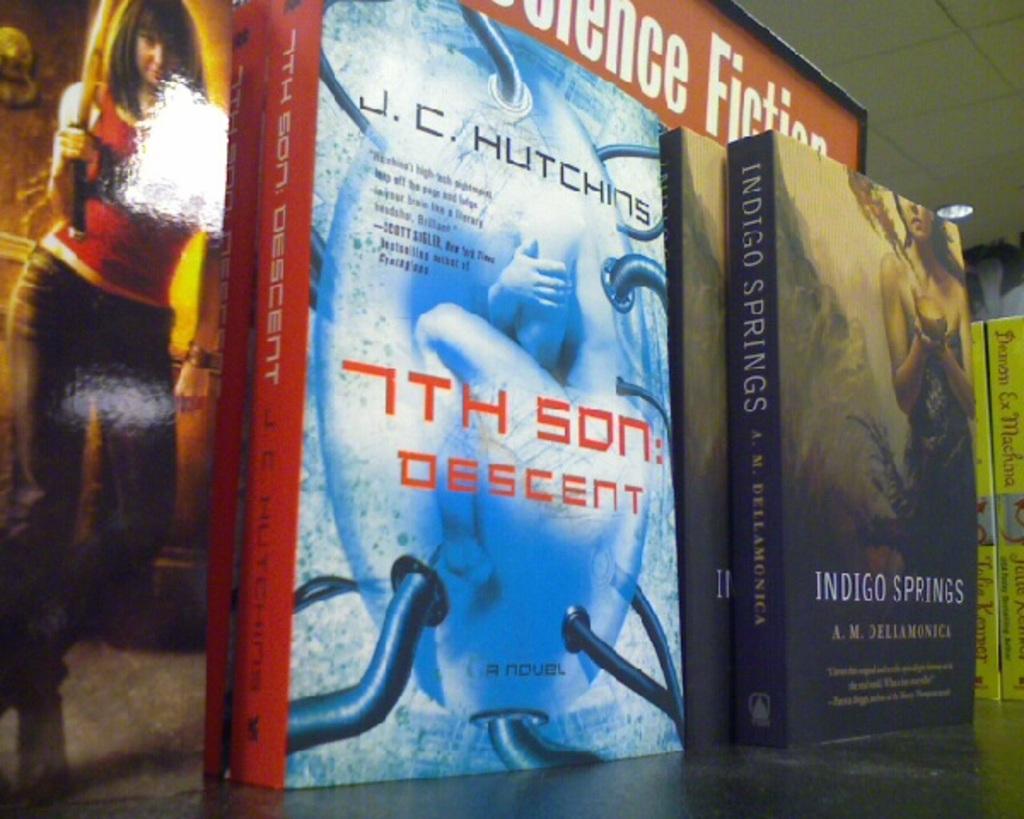What is the name of the book?
Make the answer very short. 7th son: descent. Who wrote the book on the left?
Provide a short and direct response. J.c. hutchins. 